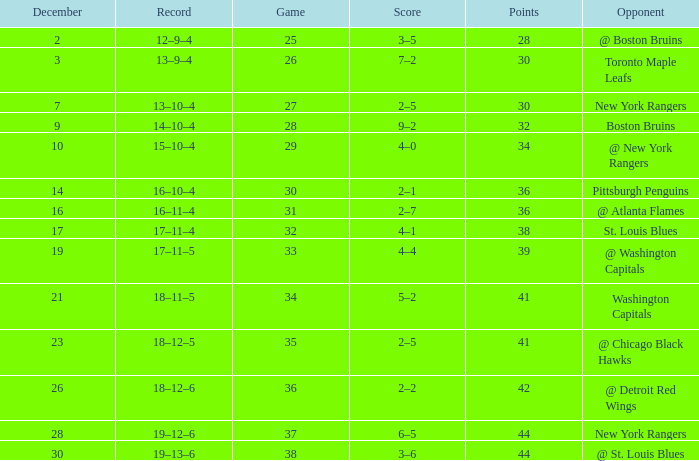Which Game has a Record of 14–10–4, and Points smaller than 32? None. 